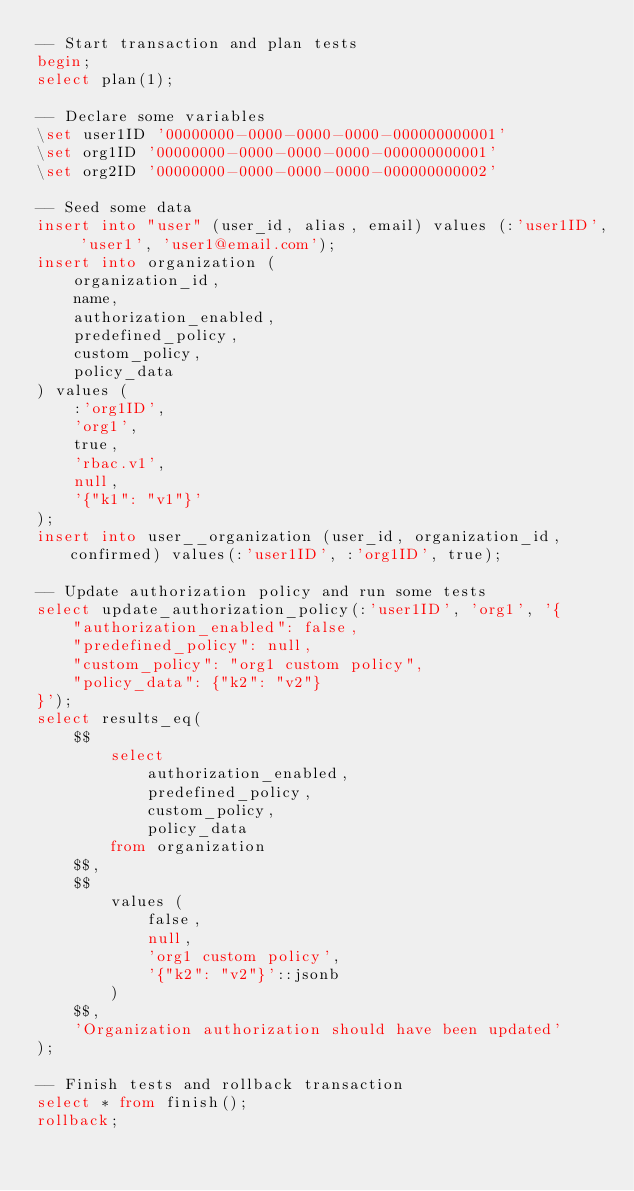<code> <loc_0><loc_0><loc_500><loc_500><_SQL_>-- Start transaction and plan tests
begin;
select plan(1);

-- Declare some variables
\set user1ID '00000000-0000-0000-0000-000000000001'
\set org1ID '00000000-0000-0000-0000-000000000001'
\set org2ID '00000000-0000-0000-0000-000000000002'

-- Seed some data
insert into "user" (user_id, alias, email) values (:'user1ID', 'user1', 'user1@email.com');
insert into organization (
    organization_id,
    name,
    authorization_enabled,
    predefined_policy,
    custom_policy,
    policy_data
) values (
    :'org1ID',
    'org1',
    true,
    'rbac.v1',
    null,
    '{"k1": "v1"}'
);
insert into user__organization (user_id, organization_id, confirmed) values(:'user1ID', :'org1ID', true);

-- Update authorization policy and run some tests
select update_authorization_policy(:'user1ID', 'org1', '{
    "authorization_enabled": false,
    "predefined_policy": null,
    "custom_policy": "org1 custom policy",
    "policy_data": {"k2": "v2"}
}');
select results_eq(
    $$
        select
            authorization_enabled,
            predefined_policy,
            custom_policy,
            policy_data
        from organization
    $$,
    $$
        values (
            false,
            null,
            'org1 custom policy',
            '{"k2": "v2"}'::jsonb
        )
    $$,
    'Organization authorization should have been updated'
);

-- Finish tests and rollback transaction
select * from finish();
rollback;
</code> 